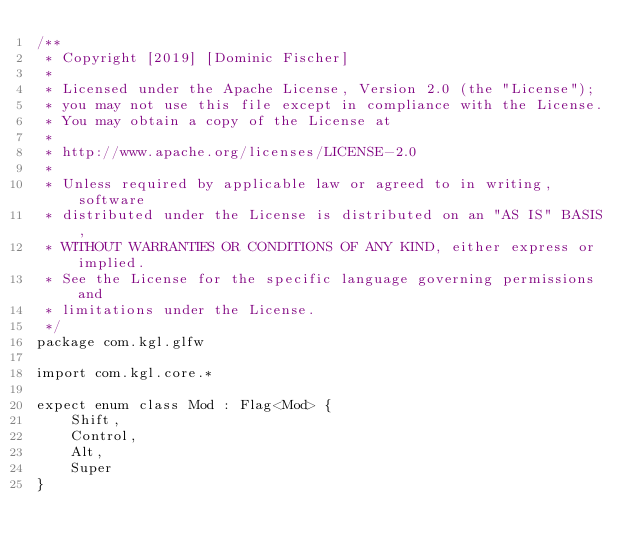Convert code to text. <code><loc_0><loc_0><loc_500><loc_500><_Kotlin_>/**
 * Copyright [2019] [Dominic Fischer]
 *
 * Licensed under the Apache License, Version 2.0 (the "License");
 * you may not use this file except in compliance with the License.
 * You may obtain a copy of the License at
 *
 * http://www.apache.org/licenses/LICENSE-2.0
 *
 * Unless required by applicable law or agreed to in writing, software
 * distributed under the License is distributed on an "AS IS" BASIS,
 * WITHOUT WARRANTIES OR CONDITIONS OF ANY KIND, either express or implied.
 * See the License for the specific language governing permissions and
 * limitations under the License.
 */
package com.kgl.glfw

import com.kgl.core.*

expect enum class Mod : Flag<Mod> {
	Shift,
	Control,
	Alt,
	Super
}
</code> 